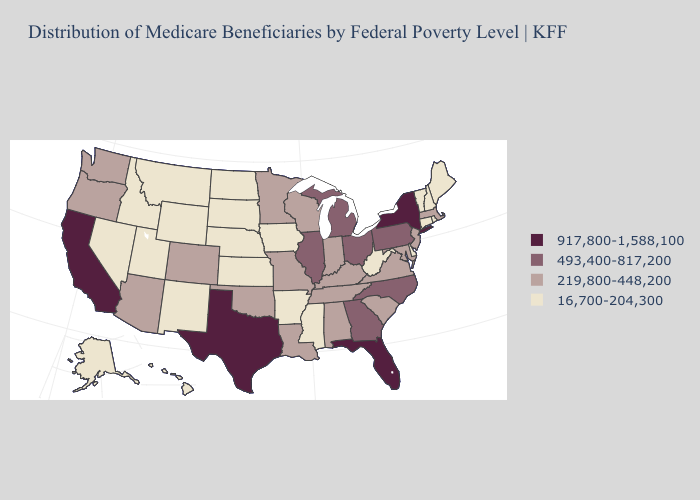Name the states that have a value in the range 219,800-448,200?
Keep it brief. Alabama, Arizona, Colorado, Indiana, Kentucky, Louisiana, Maryland, Massachusetts, Minnesota, Missouri, New Jersey, Oklahoma, Oregon, South Carolina, Tennessee, Virginia, Washington, Wisconsin. What is the lowest value in states that border Oklahoma?
Quick response, please. 16,700-204,300. Among the states that border California , which have the highest value?
Write a very short answer. Arizona, Oregon. What is the highest value in states that border Arkansas?
Concise answer only. 917,800-1,588,100. Which states have the lowest value in the USA?
Keep it brief. Alaska, Arkansas, Connecticut, Delaware, Hawaii, Idaho, Iowa, Kansas, Maine, Mississippi, Montana, Nebraska, Nevada, New Hampshire, New Mexico, North Dakota, Rhode Island, South Dakota, Utah, Vermont, West Virginia, Wyoming. Does Washington have the lowest value in the West?
Be succinct. No. Name the states that have a value in the range 16,700-204,300?
Write a very short answer. Alaska, Arkansas, Connecticut, Delaware, Hawaii, Idaho, Iowa, Kansas, Maine, Mississippi, Montana, Nebraska, Nevada, New Hampshire, New Mexico, North Dakota, Rhode Island, South Dakota, Utah, Vermont, West Virginia, Wyoming. Among the states that border North Carolina , which have the lowest value?
Short answer required. South Carolina, Tennessee, Virginia. What is the highest value in states that border Tennessee?
Answer briefly. 493,400-817,200. What is the value of Arizona?
Write a very short answer. 219,800-448,200. What is the value of North Dakota?
Give a very brief answer. 16,700-204,300. What is the value of Kansas?
Keep it brief. 16,700-204,300. What is the value of Wyoming?
Answer briefly. 16,700-204,300. How many symbols are there in the legend?
Concise answer only. 4. Does the first symbol in the legend represent the smallest category?
Answer briefly. No. 